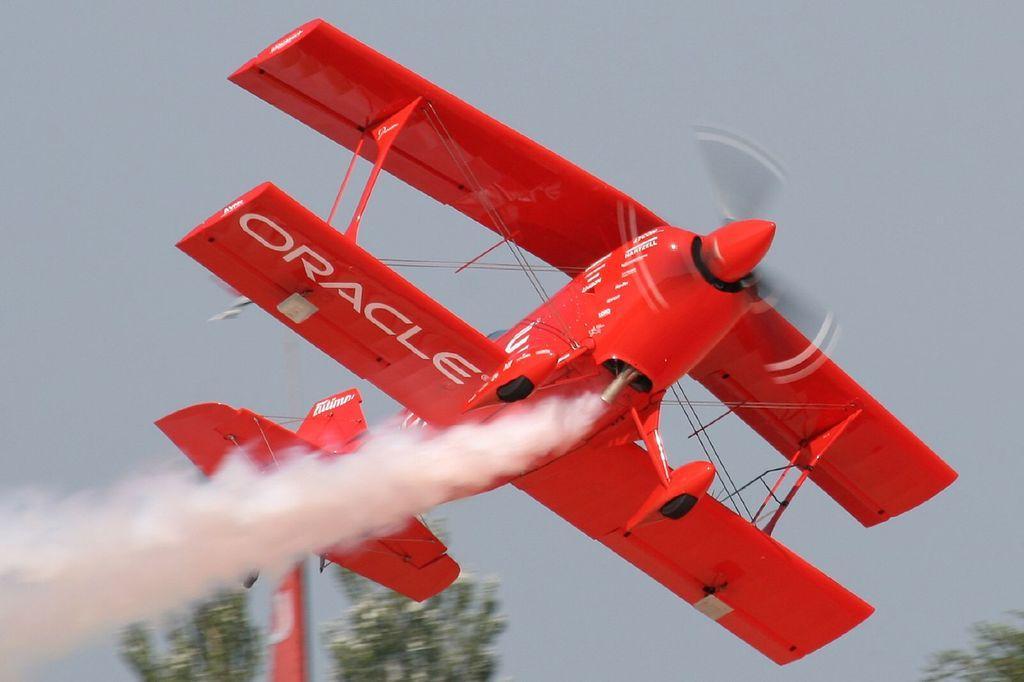How would you summarize this image in a sentence or two? In the picture we can see an aircraft which is red in color and written oracle on it and it is flying in the air leaving a smoke and in the background we can see a some part of tree and sky. 